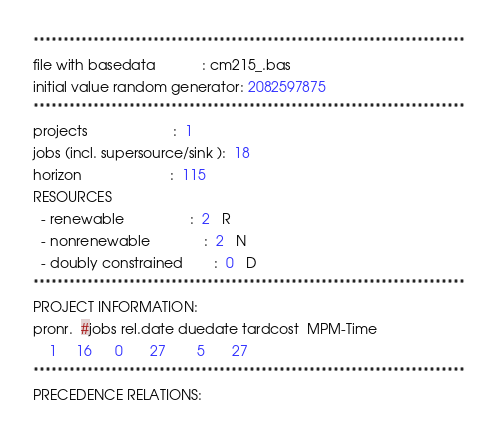<code> <loc_0><loc_0><loc_500><loc_500><_ObjectiveC_>************************************************************************
file with basedata            : cm215_.bas
initial value random generator: 2082597875
************************************************************************
projects                      :  1
jobs (incl. supersource/sink ):  18
horizon                       :  115
RESOURCES
  - renewable                 :  2   R
  - nonrenewable              :  2   N
  - doubly constrained        :  0   D
************************************************************************
PROJECT INFORMATION:
pronr.  #jobs rel.date duedate tardcost  MPM-Time
    1     16      0       27        5       27
************************************************************************
PRECEDENCE RELATIONS:</code> 